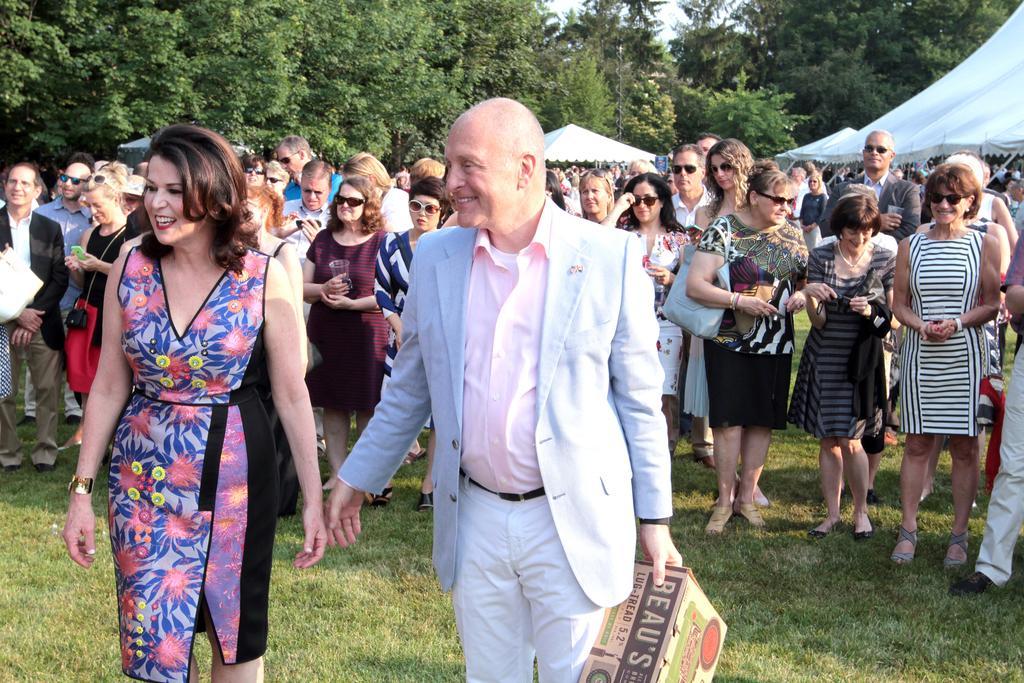How would you summarize this image in a sentence or two? There are group of people and this man holding a box and we can see grass. In the background we can see tents,trees and sky. 